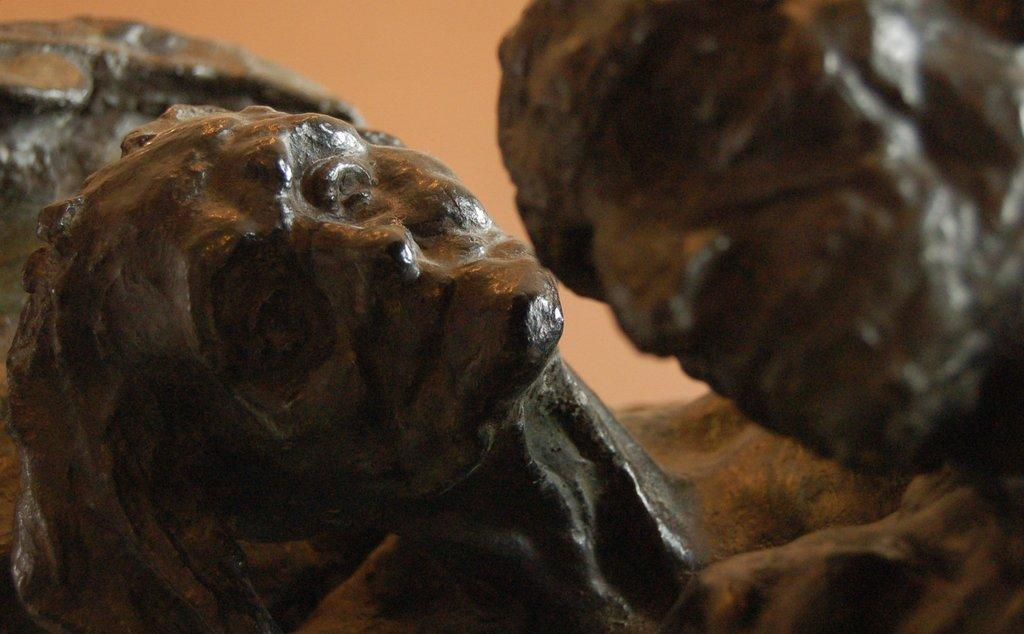What type of objects are present in the image? There are sculptures in the image. Can you describe the two main sculptures in the image? There is a man sculpture and a woman sculpture in the image. Are there any other sculptures present besides the man and woman? Yes, there are other sculptures in the image. What type of bit is being used by the man sculpture in the image? There is no bit present in the image, as it features sculptures and not people or animals using any tools or equipment. 